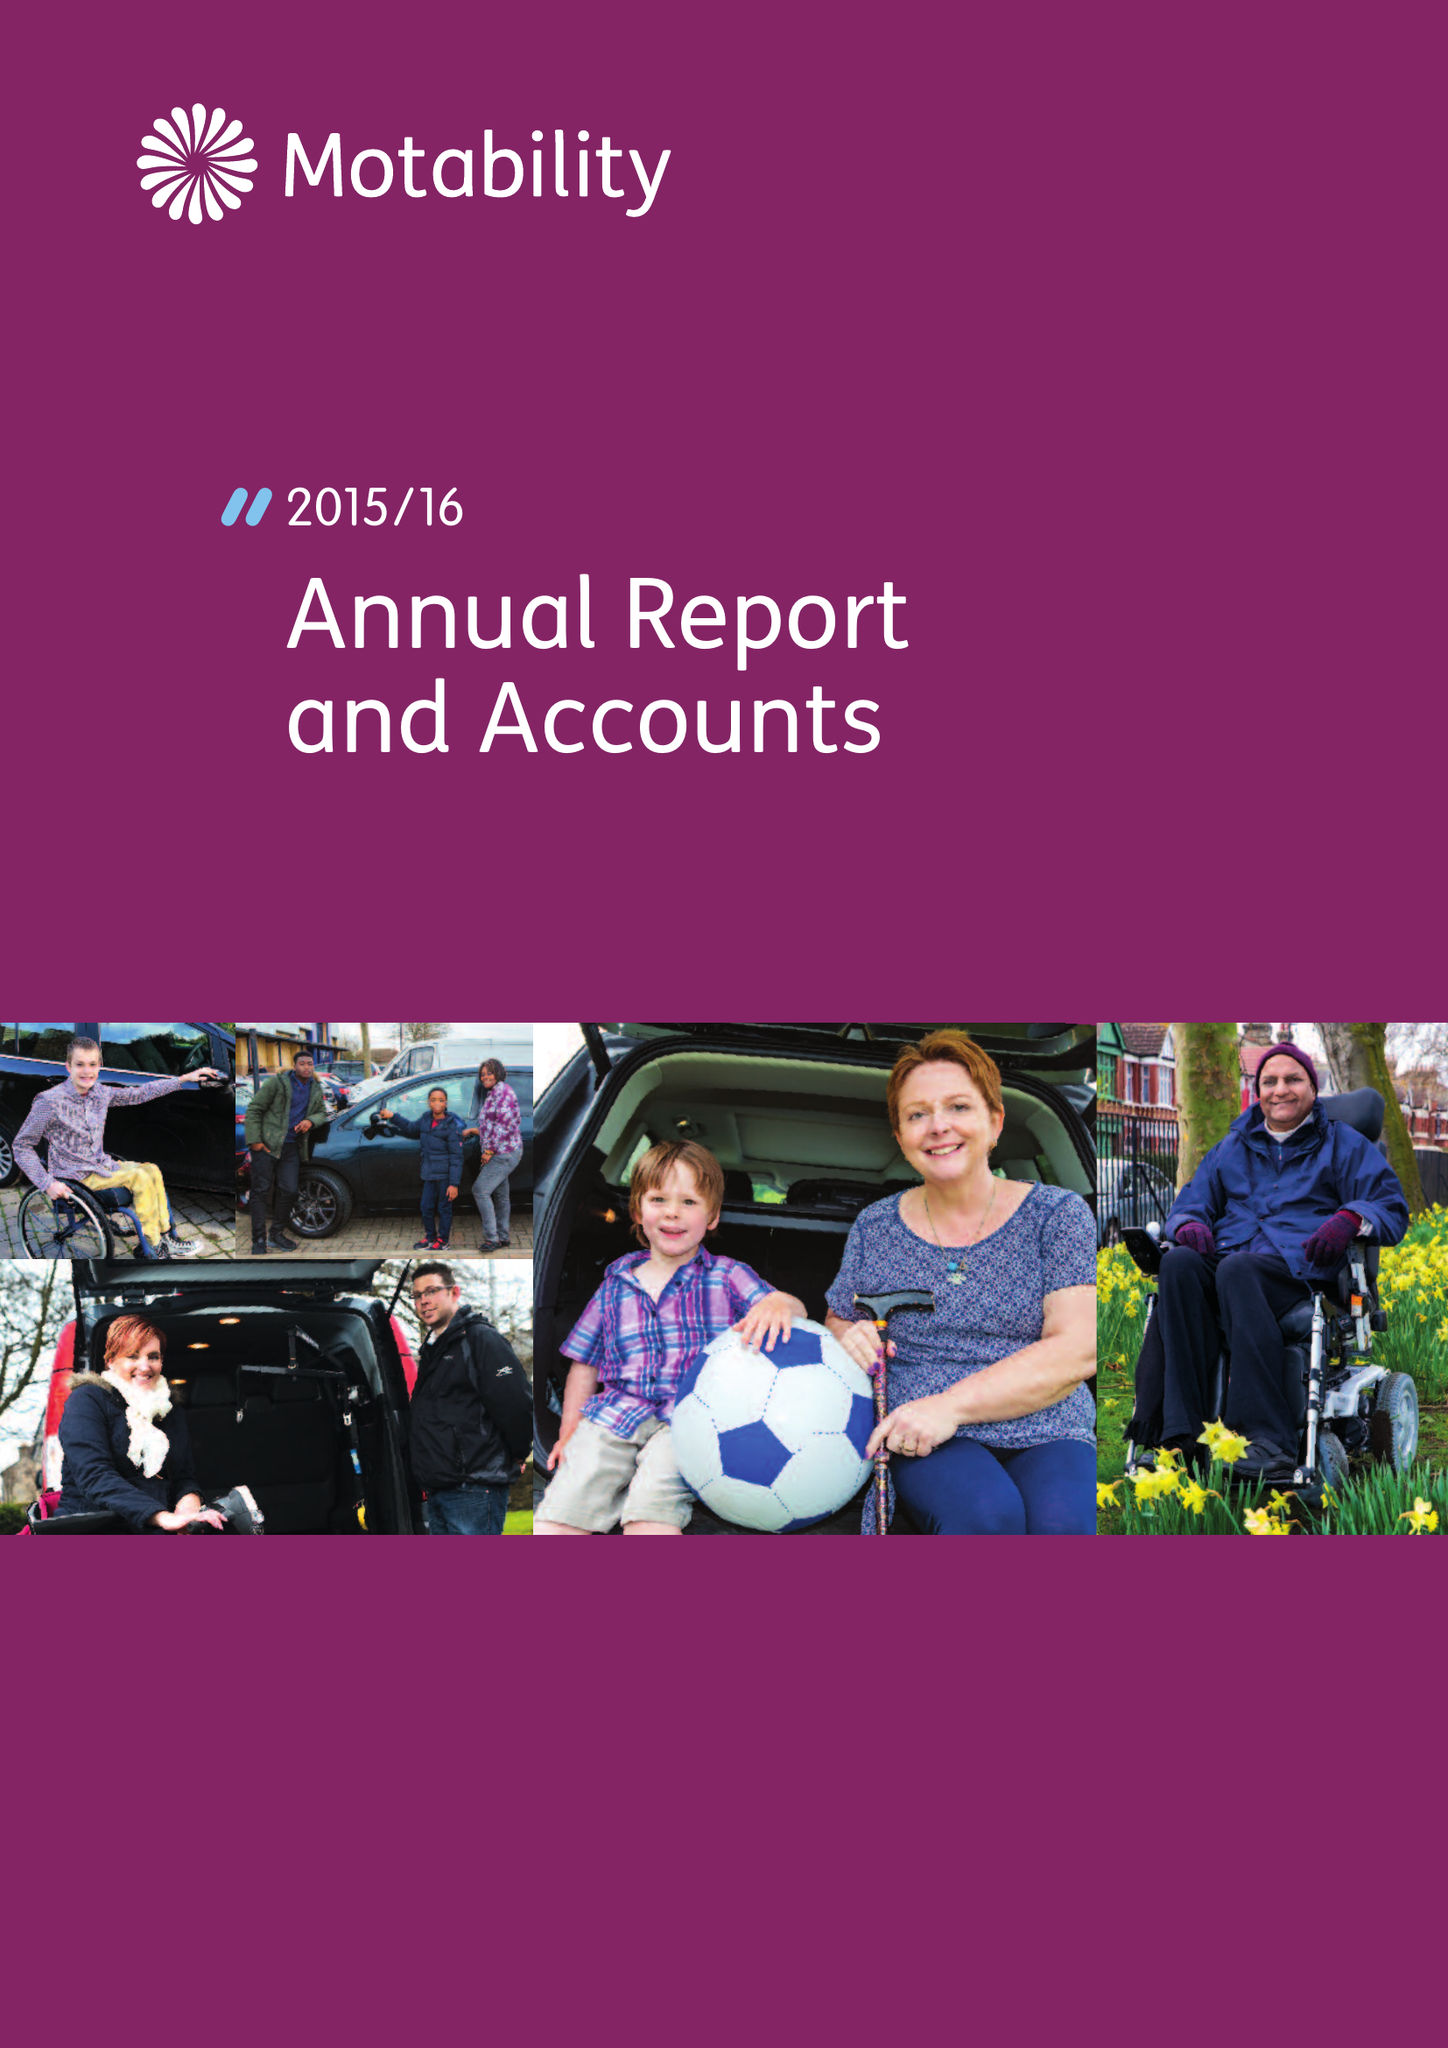What is the value for the address__street_line?
Answer the question using a single word or phrase. ROYDON ROAD 